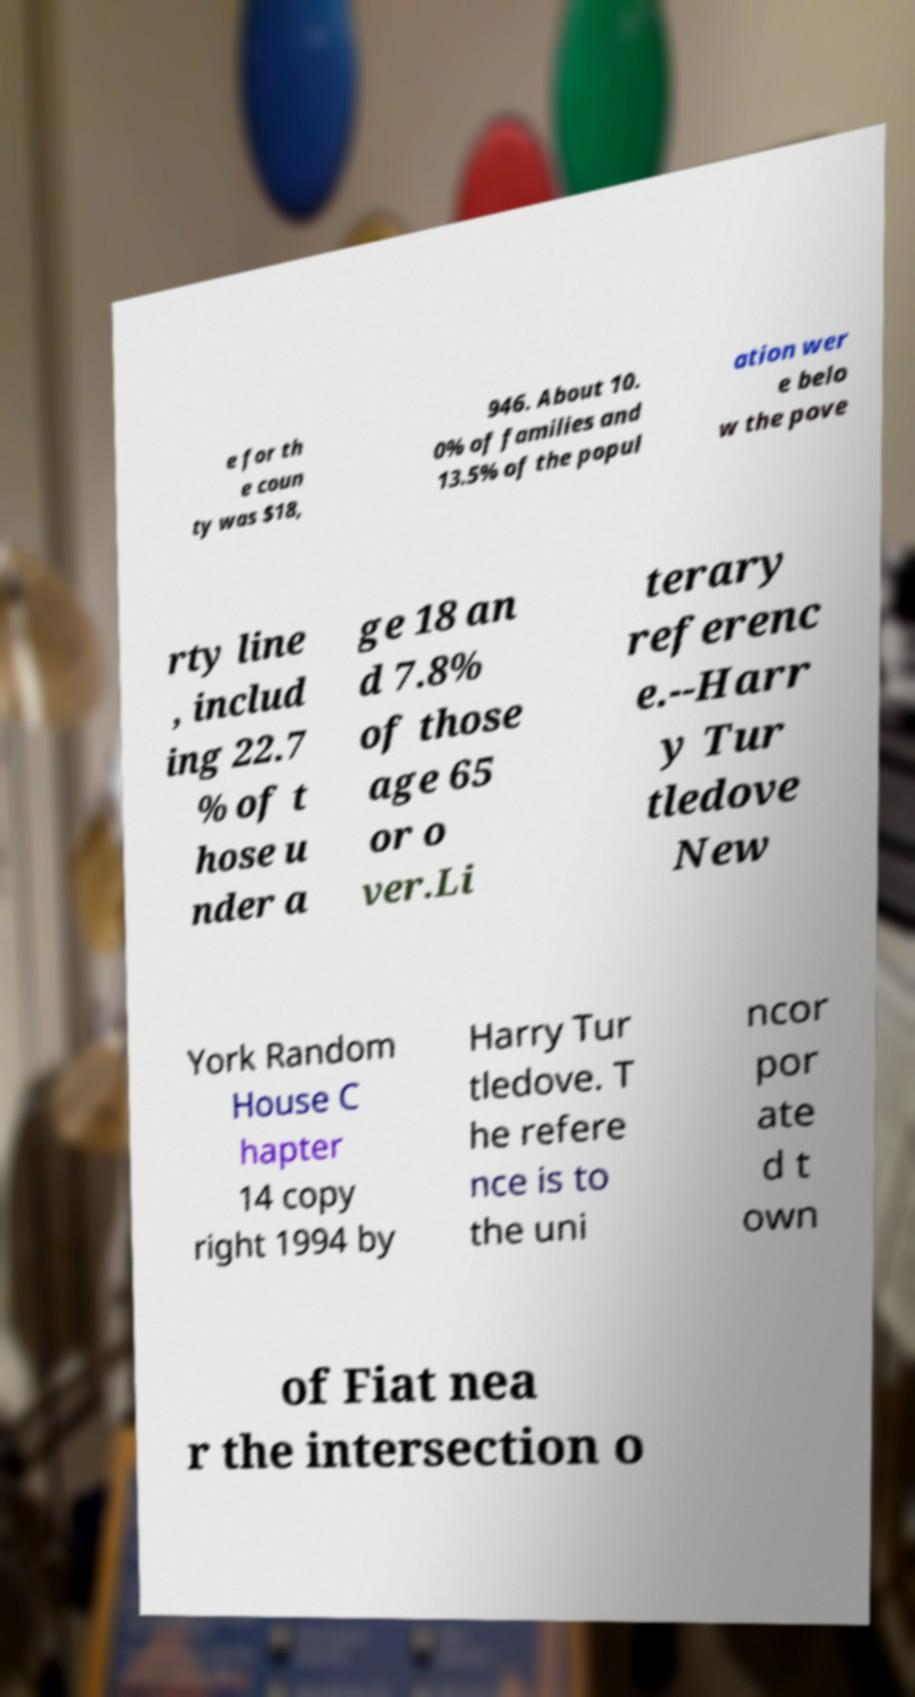Could you assist in decoding the text presented in this image and type it out clearly? e for th e coun ty was $18, 946. About 10. 0% of families and 13.5% of the popul ation wer e belo w the pove rty line , includ ing 22.7 % of t hose u nder a ge 18 an d 7.8% of those age 65 or o ver.Li terary referenc e.--Harr y Tur tledove New York Random House C hapter 14 copy right 1994 by Harry Tur tledove. T he refere nce is to the uni ncor por ate d t own of Fiat nea r the intersection o 